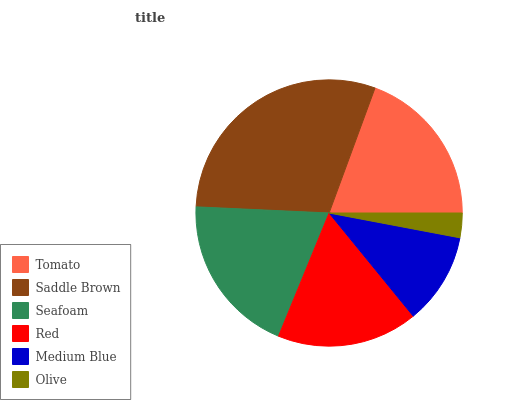Is Olive the minimum?
Answer yes or no. Yes. Is Saddle Brown the maximum?
Answer yes or no. Yes. Is Seafoam the minimum?
Answer yes or no. No. Is Seafoam the maximum?
Answer yes or no. No. Is Saddle Brown greater than Seafoam?
Answer yes or no. Yes. Is Seafoam less than Saddle Brown?
Answer yes or no. Yes. Is Seafoam greater than Saddle Brown?
Answer yes or no. No. Is Saddle Brown less than Seafoam?
Answer yes or no. No. Is Tomato the high median?
Answer yes or no. Yes. Is Red the low median?
Answer yes or no. Yes. Is Medium Blue the high median?
Answer yes or no. No. Is Medium Blue the low median?
Answer yes or no. No. 